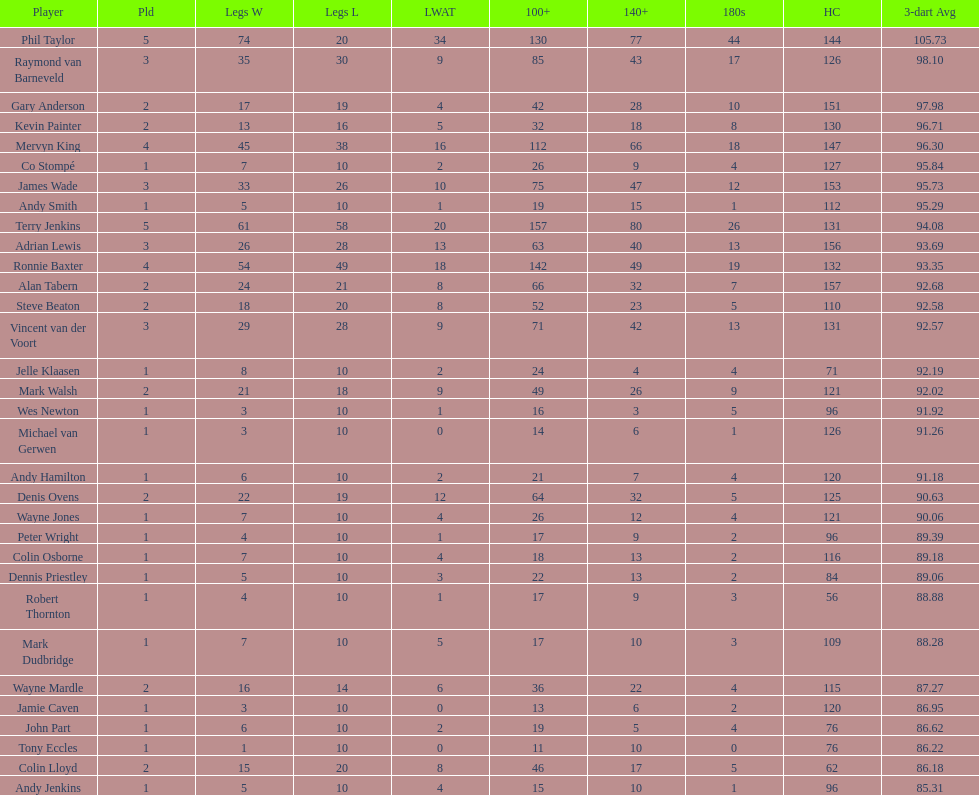Who won the highest number of legs in the 2009 world matchplay? Phil Taylor. 